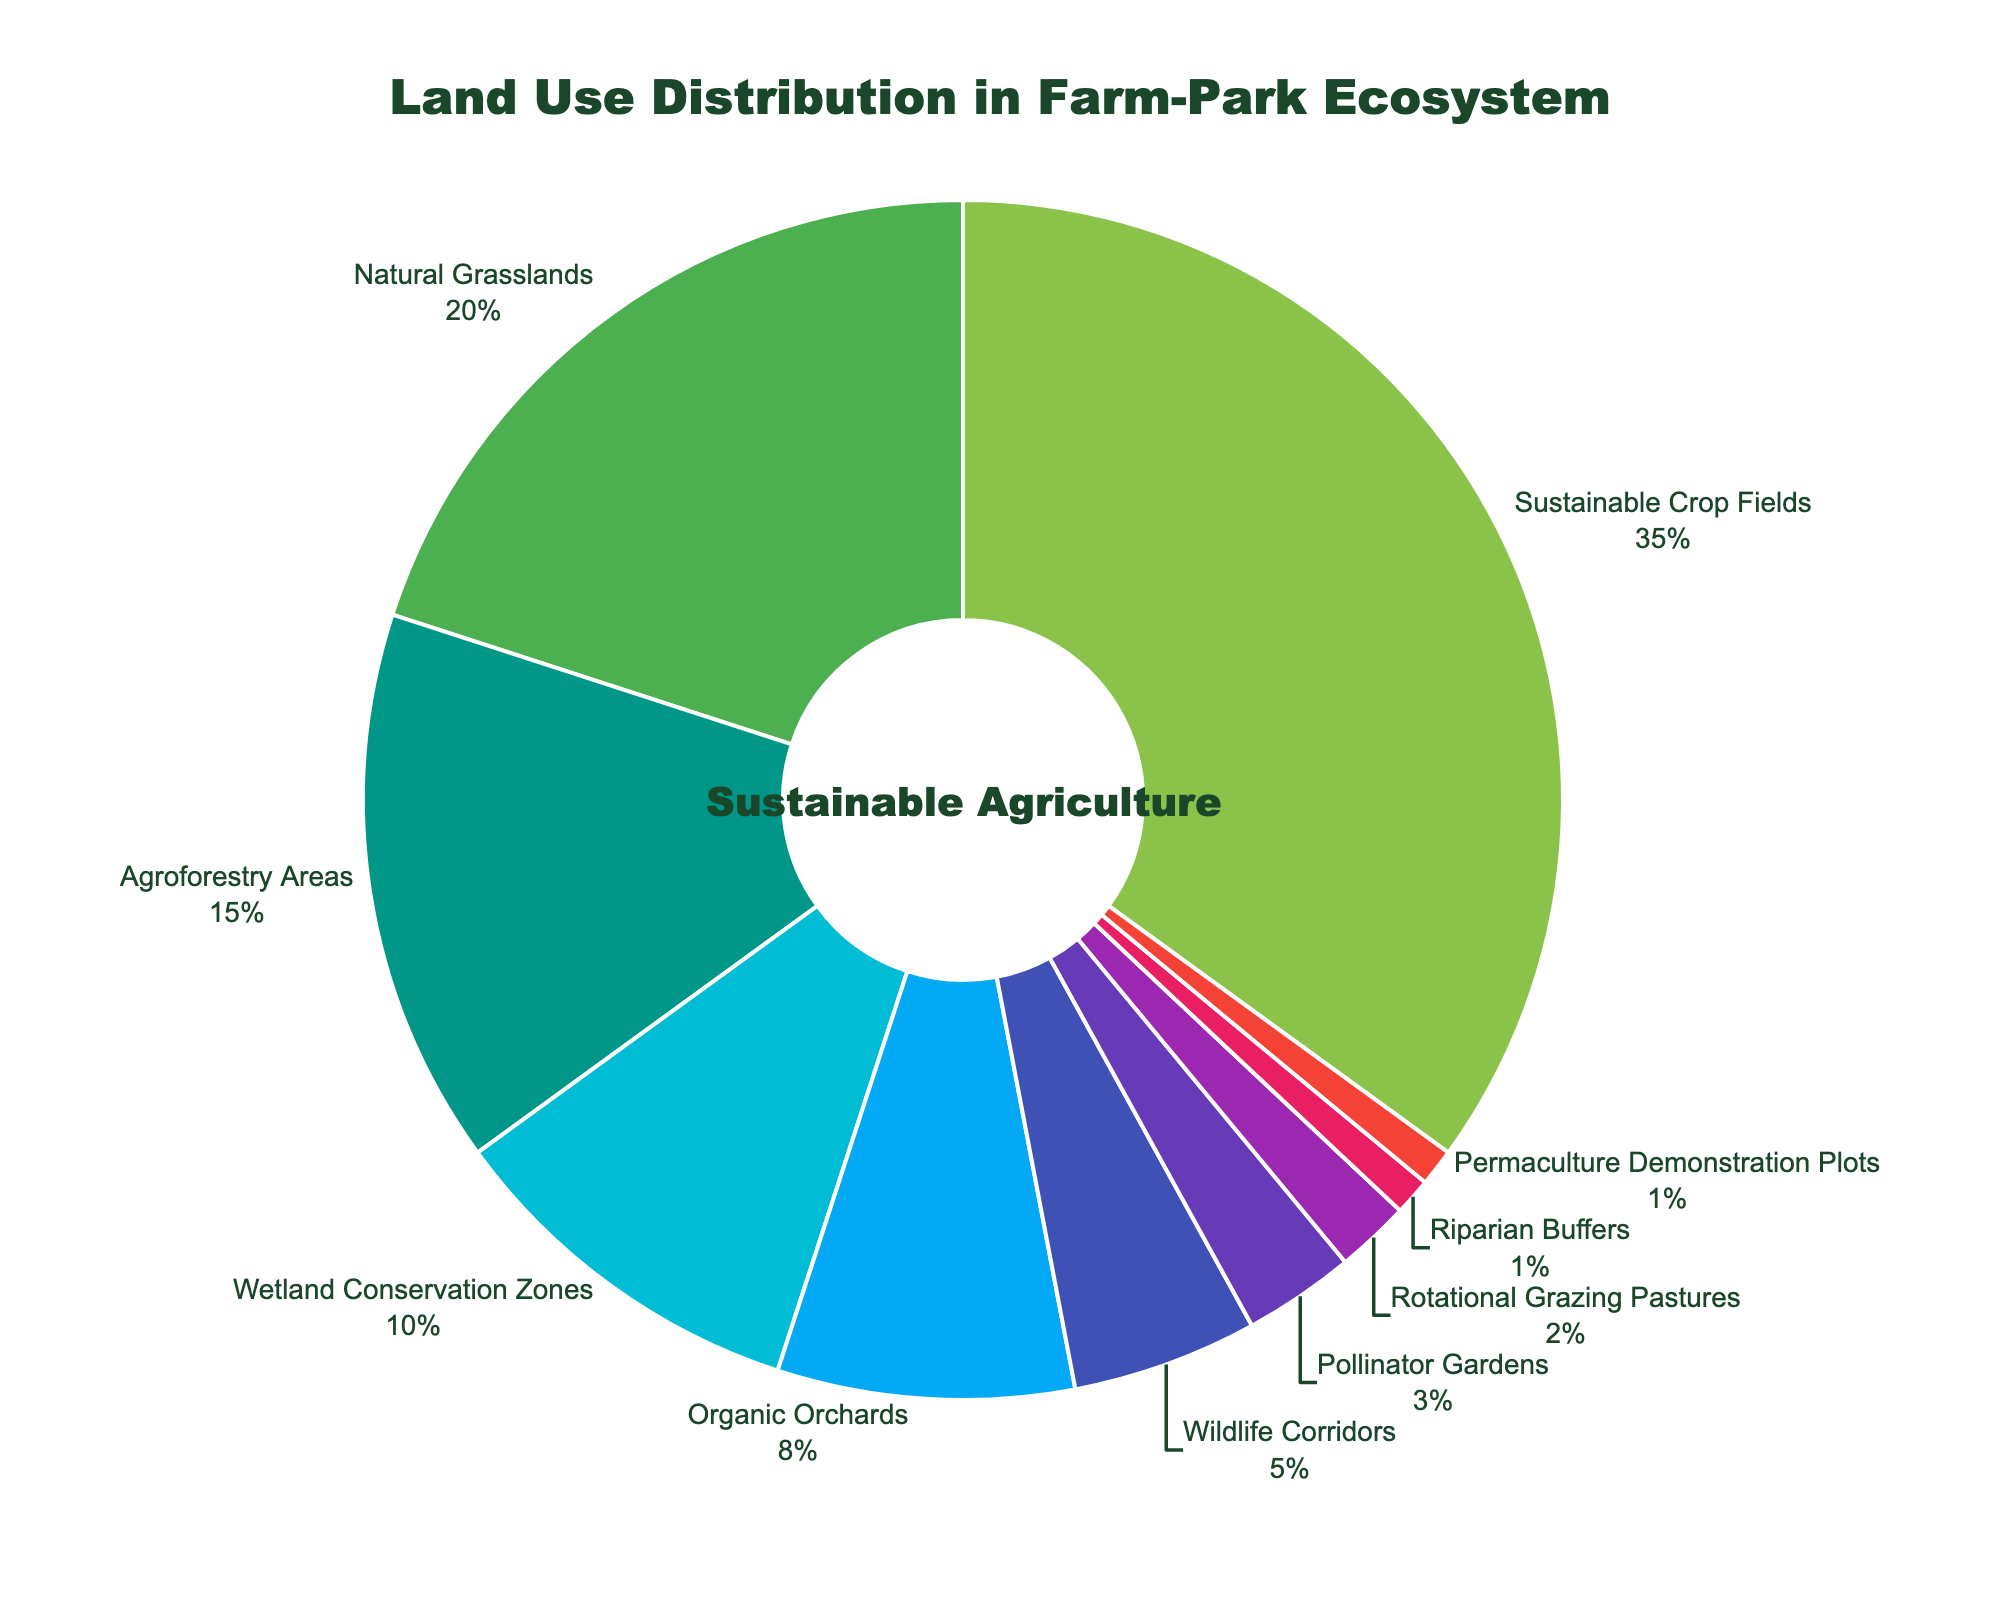What is the most dominant land use type in the farm-park ecosystem? The pie chart shows that Sustainable Crop Fields have the largest section, representing 35%, which is the highest percentage among all the land use types.
Answer: Sustainable Crop Fields What is the combined percentage of Agroforestry Areas and Wildlife Corridors? From the chart, Agroforestry Areas account for 15% and Wildlife Corridors account for 5%. Adding these together: 15% + 5% = 20%.
Answer: 20% How does the percentage of Wetland Conservation Zones compare to that of Organic Orchards? Wetland Conservation Zones are shown to take up 10% of the land, while Organic Orchards cover 8%. Therefore, Wetland Conservation Zones have a higher percentage.
Answer: Wetland Conservation Zones have a higher percentage Which land use type occupies the smallest area? According to the chart, both Riparian Buffers and Permaculture Demonstration Plots occupy 1%, which is the smallest percentage among all land use types.
Answer: Riparian Buffers and Permaculture Demonstration Plots Which land use types combined make up more than 50% of the land? By analyzing the chart and adding the percentages: Sustainable Crop Fields (35%), Natural Grasslands (20%), this already exceeds 50% (35% + 20% = 55%).
Answer: Sustainable Crop Fields and Natural Grasslands What is the total percentage of all varieties of crop-related land uses (including Sustainable Crop Fields, Agroforestry Areas, Organic Orchards, and Permaculture Demonstration Plots)? Summing the percentages of crop-related land uses: Sustainable Crop Fields (35%), Agroforestry Areas (15%), Organic Orchards (8%), and Permaculture Demonstration Plots (1%) gives: 35% + 15% + 8% + 1% = 59%.
Answer: 59% How much larger is the area dedicated to Pollinator Gardens compared to Rotational Grazing Pastures? Pollinator Gardens represent 3% of the land use and Rotational Grazing Pastures represent 2%, so the difference is: 3% - 2% = 1%.
Answer: 1% If you total the land use percentages for Natural Grasslands, Wetland Conservation Zones, and Wildlife Corridors, what do you get? Adding the respective percentages: Natural Grasslands (20%), Wetland Conservation Zones (10%), and Wildlife Corridors (5%) results in: 20% + 10% + 5% = 35%.
Answer: 35% How does the percentage of Agroforestry Areas compare with the percentage of Wetland Conservation Zones? Agroforestry Areas occupy 15% of the land, while Wetland Conservation Zones cover 10%. Thus, Agroforestry Areas have a higher percentage.
Answer: Agroforestry Areas have a higher percentage Which land use types occupy less than 5% of the land each? Pollinator Gardens (3%), Rotational Grazing Pastures (2%), Riparian Buffers (1%), and Permaculture Demonstration Plots (1%) all occupy less than 5% of the land.
Answer: Pollinator Gardens, Rotational Grazing Pastures, Riparian Buffers, and Permaculture Demonstration Plots 